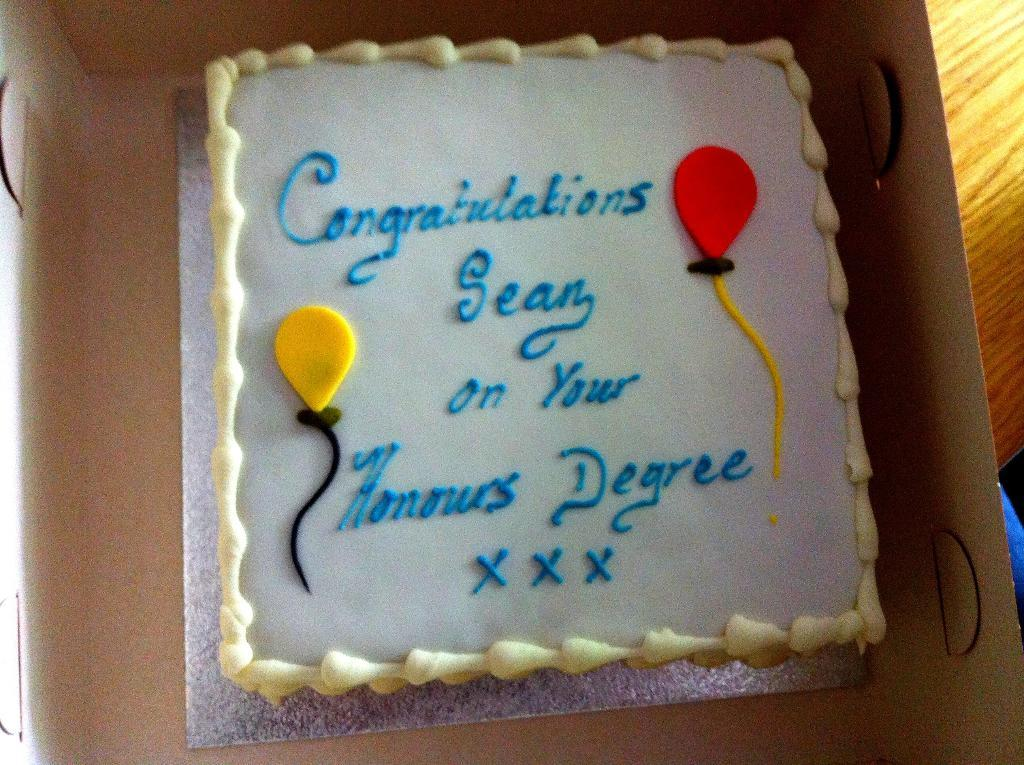What is the main subject of the image? The main subject of the image is a cake. How is the cake being stored or transported? The cake is in a box. On what surface is the box with the cake placed? The box with the cake is placed on a wooden table. How many lizards can be seen crawling on the cake in the image? There are no lizards present in the image. What type of teeth can be seen on the cake in the image? There are no teeth visible on the cake in the image. 